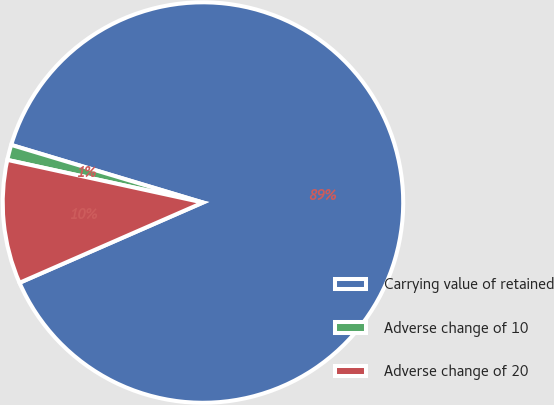<chart> <loc_0><loc_0><loc_500><loc_500><pie_chart><fcel>Carrying value of retained<fcel>Adverse change of 10<fcel>Adverse change of 20<nl><fcel>88.79%<fcel>1.23%<fcel>9.98%<nl></chart> 